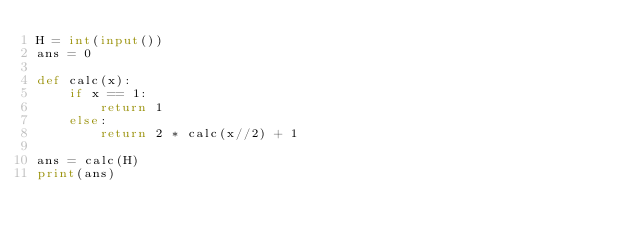<code> <loc_0><loc_0><loc_500><loc_500><_Python_>H = int(input())
ans = 0

def calc(x):
    if x == 1:
        return 1
    else:
        return 2 * calc(x//2) + 1

ans = calc(H)
print(ans)</code> 